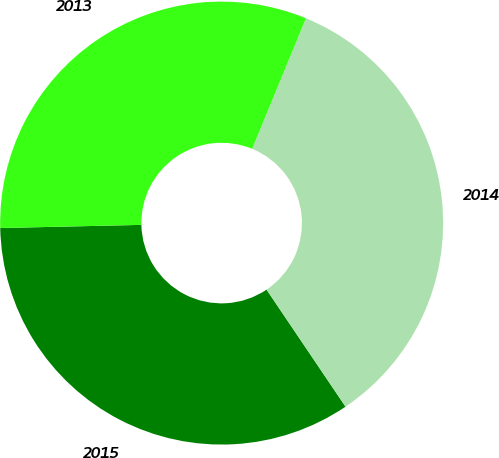Convert chart to OTSL. <chart><loc_0><loc_0><loc_500><loc_500><pie_chart><fcel>2015<fcel>2014<fcel>2013<nl><fcel>34.09%<fcel>34.34%<fcel>31.57%<nl></chart> 